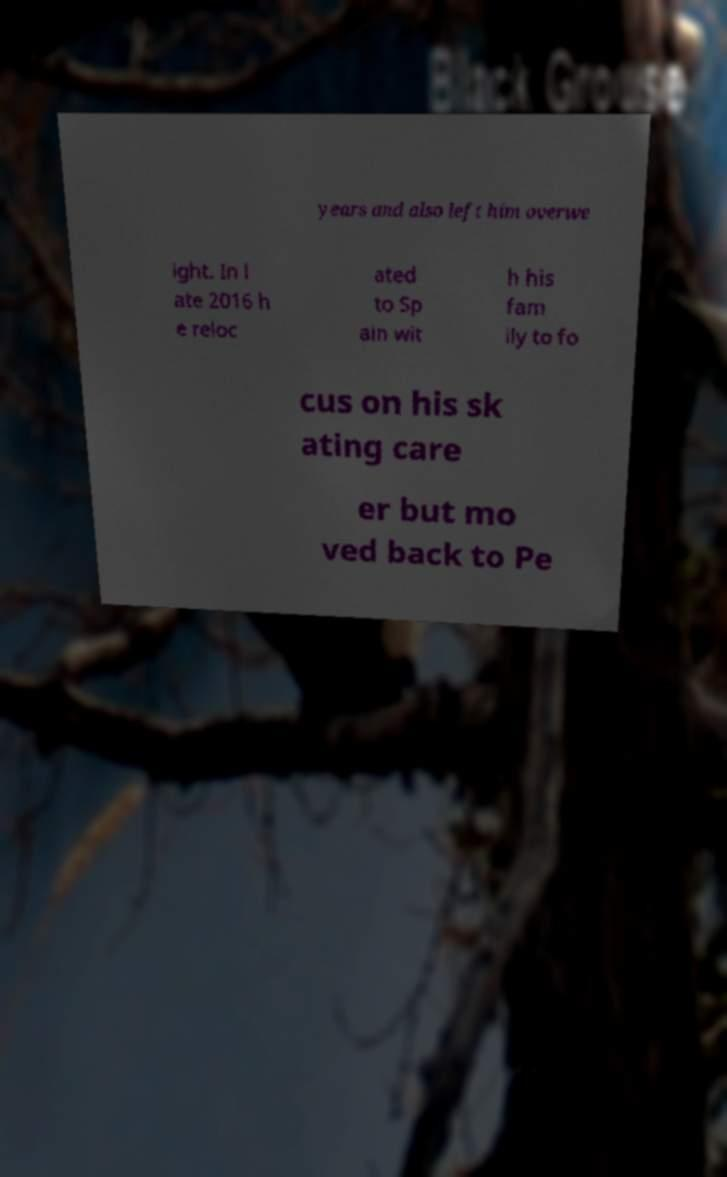What messages or text are displayed in this image? I need them in a readable, typed format. years and also left him overwe ight. In l ate 2016 h e reloc ated to Sp ain wit h his fam ily to fo cus on his sk ating care er but mo ved back to Pe 